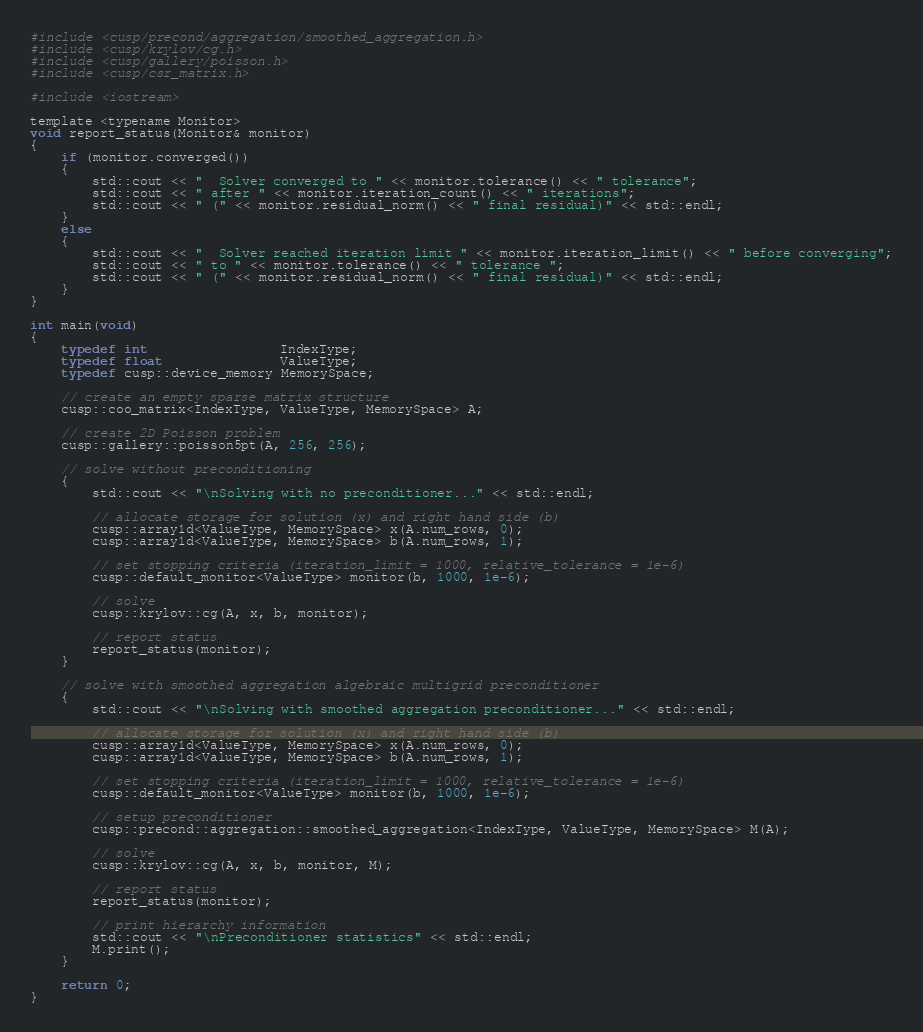<code> <loc_0><loc_0><loc_500><loc_500><_Cuda_>#include <cusp/precond/aggregation/smoothed_aggregation.h>
#include <cusp/krylov/cg.h>
#include <cusp/gallery/poisson.h>
#include <cusp/csr_matrix.h>

#include <iostream>

template <typename Monitor>
void report_status(Monitor& monitor)
{
    if (monitor.converged())
    {
        std::cout << "  Solver converged to " << monitor.tolerance() << " tolerance";
        std::cout << " after " << monitor.iteration_count() << " iterations";
        std::cout << " (" << monitor.residual_norm() << " final residual)" << std::endl;
    }
    else
    {
        std::cout << "  Solver reached iteration limit " << monitor.iteration_limit() << " before converging";
        std::cout << " to " << monitor.tolerance() << " tolerance ";
        std::cout << " (" << monitor.residual_norm() << " final residual)" << std::endl;
    }
}

int main(void)
{
    typedef int                 IndexType;
    typedef float               ValueType;
    typedef cusp::device_memory MemorySpace;

    // create an empty sparse matrix structure
    cusp::coo_matrix<IndexType, ValueType, MemorySpace> A;

    // create 2D Poisson problem
    cusp::gallery::poisson5pt(A, 256, 256);

    // solve without preconditioning
    {
        std::cout << "\nSolving with no preconditioner..." << std::endl;
    
        // allocate storage for solution (x) and right hand side (b)
        cusp::array1d<ValueType, MemorySpace> x(A.num_rows, 0);
        cusp::array1d<ValueType, MemorySpace> b(A.num_rows, 1);

        // set stopping criteria (iteration_limit = 1000, relative_tolerance = 1e-6)
        cusp::default_monitor<ValueType> monitor(b, 1000, 1e-6);
        
        // solve
        cusp::krylov::cg(A, x, b, monitor);

        // report status
        report_status(monitor);
    }

    // solve with smoothed aggregation algebraic multigrid preconditioner
    {
        std::cout << "\nSolving with smoothed aggregation preconditioner..." << std::endl;
        
        // allocate storage for solution (x) and right hand side (b)
        cusp::array1d<ValueType, MemorySpace> x(A.num_rows, 0);
        cusp::array1d<ValueType, MemorySpace> b(A.num_rows, 1);

        // set stopping criteria (iteration_limit = 1000, relative_tolerance = 1e-6)
        cusp::default_monitor<ValueType> monitor(b, 1000, 1e-6);

        // setup preconditioner
        cusp::precond::aggregation::smoothed_aggregation<IndexType, ValueType, MemorySpace> M(A);
        
        // solve
        cusp::krylov::cg(A, x, b, monitor, M);
        
        // report status
        report_status(monitor);
        
        // print hierarchy information
        std::cout << "\nPreconditioner statistics" << std::endl;
        M.print();
    }

    return 0;
}

</code> 